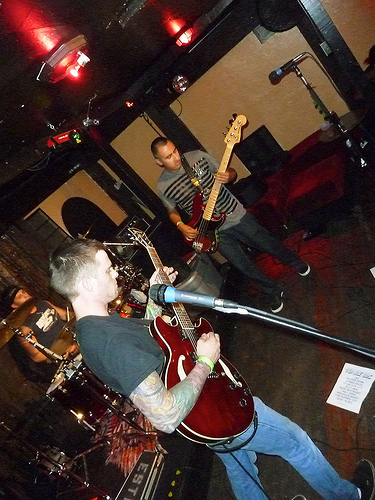<image>
Can you confirm if the man is on the floor? Yes. Looking at the image, I can see the man is positioned on top of the floor, with the floor providing support. 